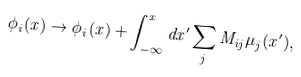<formula> <loc_0><loc_0><loc_500><loc_500>\phi _ { i } ( x ) \rightarrow \phi _ { i } ( x ) + \int _ { - \infty } ^ { x } d x ^ { \prime } \sum _ { j } M _ { i j } \mu _ { j } ( x ^ { \prime } ) ,</formula> 